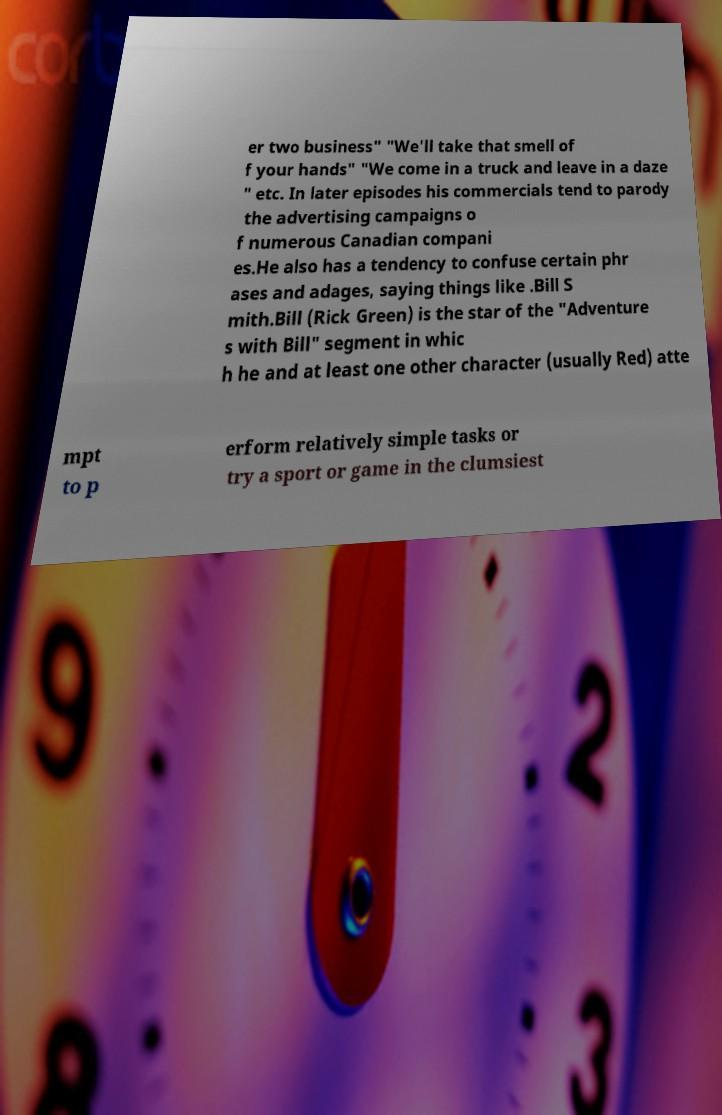Please identify and transcribe the text found in this image. er two business" "We'll take that smell of f your hands" "We come in a truck and leave in a daze " etc. In later episodes his commercials tend to parody the advertising campaigns o f numerous Canadian compani es.He also has a tendency to confuse certain phr ases and adages, saying things like .Bill S mith.Bill (Rick Green) is the star of the "Adventure s with Bill" segment in whic h he and at least one other character (usually Red) atte mpt to p erform relatively simple tasks or try a sport or game in the clumsiest 